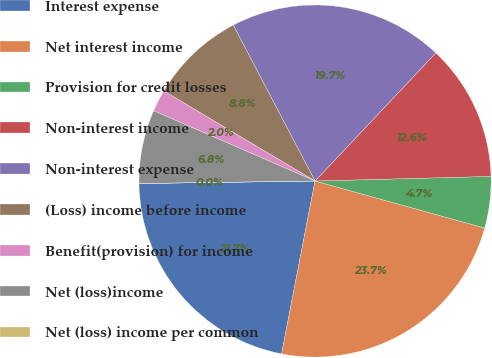<chart> <loc_0><loc_0><loc_500><loc_500><pie_chart><fcel>Interest expense<fcel>Net interest income<fcel>Provision for credit losses<fcel>Non-interest income<fcel>Non-interest expense<fcel>(Loss) income before income<fcel>Benefit(provision) for income<fcel>Net (loss)income<fcel>Net (loss) income per common<nl><fcel>21.73%<fcel>23.74%<fcel>4.72%<fcel>12.55%<fcel>19.72%<fcel>8.77%<fcel>2.01%<fcel>6.76%<fcel>0.0%<nl></chart> 